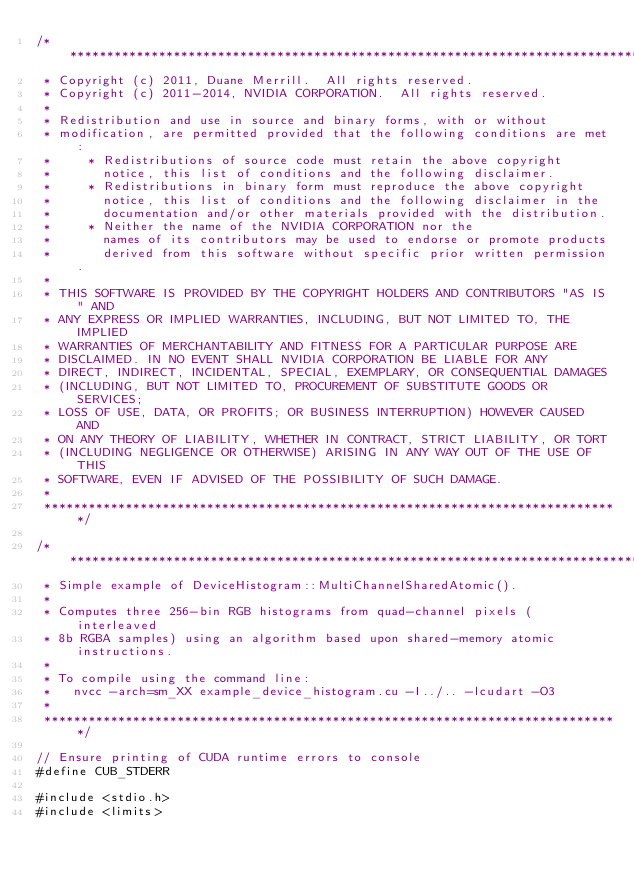Convert code to text. <code><loc_0><loc_0><loc_500><loc_500><_Cuda_>/******************************************************************************
 * Copyright (c) 2011, Duane Merrill.  All rights reserved.
 * Copyright (c) 2011-2014, NVIDIA CORPORATION.  All rights reserved.
 *
 * Redistribution and use in source and binary forms, with or without
 * modification, are permitted provided that the following conditions are met:
 *     * Redistributions of source code must retain the above copyright
 *       notice, this list of conditions and the following disclaimer.
 *     * Redistributions in binary form must reproduce the above copyright
 *       notice, this list of conditions and the following disclaimer in the
 *       documentation and/or other materials provided with the distribution.
 *     * Neither the name of the NVIDIA CORPORATION nor the
 *       names of its contributors may be used to endorse or promote products
 *       derived from this software without specific prior written permission.
 *
 * THIS SOFTWARE IS PROVIDED BY THE COPYRIGHT HOLDERS AND CONTRIBUTORS "AS IS" AND
 * ANY EXPRESS OR IMPLIED WARRANTIES, INCLUDING, BUT NOT LIMITED TO, THE IMPLIED
 * WARRANTIES OF MERCHANTABILITY AND FITNESS FOR A PARTICULAR PURPOSE ARE
 * DISCLAIMED. IN NO EVENT SHALL NVIDIA CORPORATION BE LIABLE FOR ANY
 * DIRECT, INDIRECT, INCIDENTAL, SPECIAL, EXEMPLARY, OR CONSEQUENTIAL DAMAGES
 * (INCLUDING, BUT NOT LIMITED TO, PROCUREMENT OF SUBSTITUTE GOODS OR SERVICES;
 * LOSS OF USE, DATA, OR PROFITS; OR BUSINESS INTERRUPTION) HOWEVER CAUSED AND
 * ON ANY THEORY OF LIABILITY, WHETHER IN CONTRACT, STRICT LIABILITY, OR TORT
 * (INCLUDING NEGLIGENCE OR OTHERWISE) ARISING IN ANY WAY OUT OF THE USE OF THIS
 * SOFTWARE, EVEN IF ADVISED OF THE POSSIBILITY OF SUCH DAMAGE.
 *
 ******************************************************************************/

/******************************************************************************
 * Simple example of DeviceHistogram::MultiChannelSharedAtomic().
 *
 * Computes three 256-bin RGB histograms from quad-channel pixels (interleaved
 * 8b RGBA samples) using an algorithm based upon shared-memory atomic instructions.
 *
 * To compile using the command line:
 *   nvcc -arch=sm_XX example_device_histogram.cu -I../.. -lcudart -O3
 *
 ******************************************************************************/

// Ensure printing of CUDA runtime errors to console
#define CUB_STDERR

#include <stdio.h>
#include <limits>
</code> 